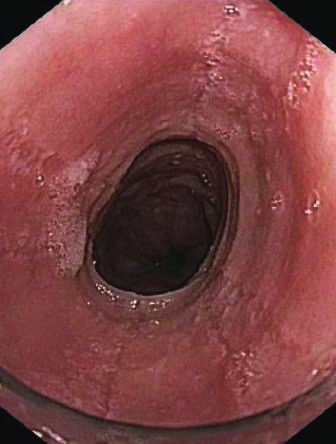what reveals circumferential rings in the proximal esophagus of this patient with eosinophilic esophagitis?
Answer the question using a single word or phrase. Endoscopy 